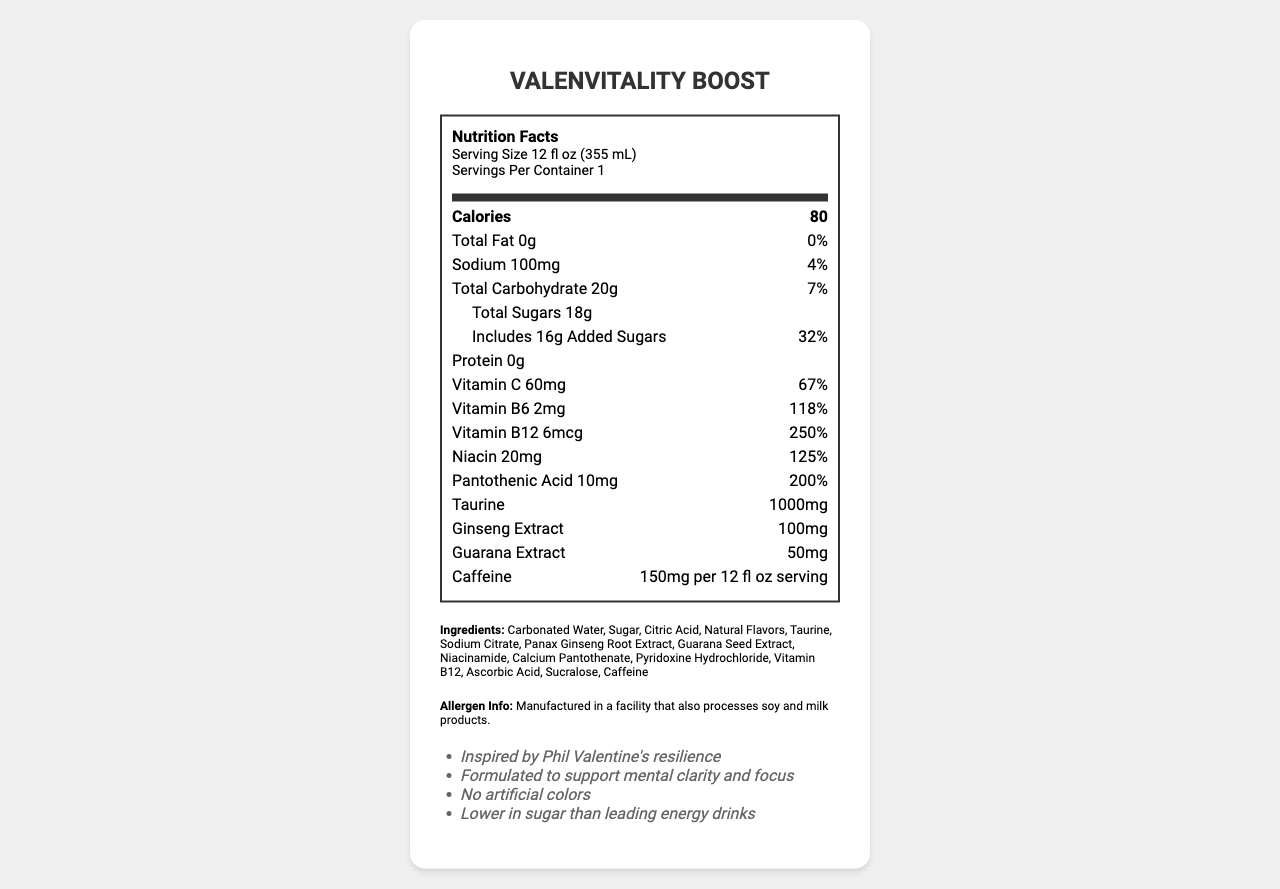what is the serving size of ValenVitality Boost? The serving size is listed directly under the Nutrition Facts header.
Answer: 12 fl oz (355 mL) how many calories does one serving of ValenVitality Boost contain? This value is located prominently in the "Calories" section of the Nutrition Facts Label.
Answer: 80 calories how much vitamin C is in one serving of ValenVitality Boost? The amount of vitamin C is stated in the Nutrition Facts Label along with its daily value percentage.
Answer: 60mg what percentage of the daily value for sodium does one serving of ValenVitality Boost provide? The percentage daily value for sodium is listed next to the amount of sodium.
Answer: 4% what is the amount of caffeine in one serving of ValenVitality Boost? The caffeine content is listed at the bottom of the Nutrition Facts Label.
Answer: 150mg which of the following is NOT an ingredient in ValenVitality Boost?
A. Sucralose
B. Carbonated Water
C. High Fructose Corn Syrup High Fructose Corn Syrup is not listed among the ingredients in the document.
Answer: C how many added sugars are in one serving of ValenVitality Boost?
A. 10g
B. 12g
C. 16g
D. 18g The added sugars are listed as 16g on the Nutrition Facts Label.
Answer: C does ValenVitality Boost contain any protein? The label states there is 0g of protein in one serving.
Answer: No is ValenVitality Boost suitable for individuals with soy allergies? The document states it is manufactured in a facility that processes soy, but it doesn't explicitly mention if it is suitable for individuals with soy allergies.
Answer: Not enough information summarize the main features of ValenVitality Boost. The summary captures the key nutritional information, beneficial ingredients, and marketing claims presented in the document.
Answer: ValenVitality Boost is a healthier energy drink alternative inspired by Phil Valentine. It contains 80 calories per serving, with beneficial vitamins such as Vitamin C, B6, B12, niacin, and pantothenic acid. It also includes 1000mg of taurine, 100mg of ginseng extract, and 50mg of guarana extract. The product is marketed as supporting mental clarity and focus and is lower in sugar than leading energy drinks. 